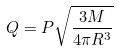Convert formula to latex. <formula><loc_0><loc_0><loc_500><loc_500>Q = P \sqrt { \frac { 3 M } { 4 \pi R ^ { 3 } } }</formula> 